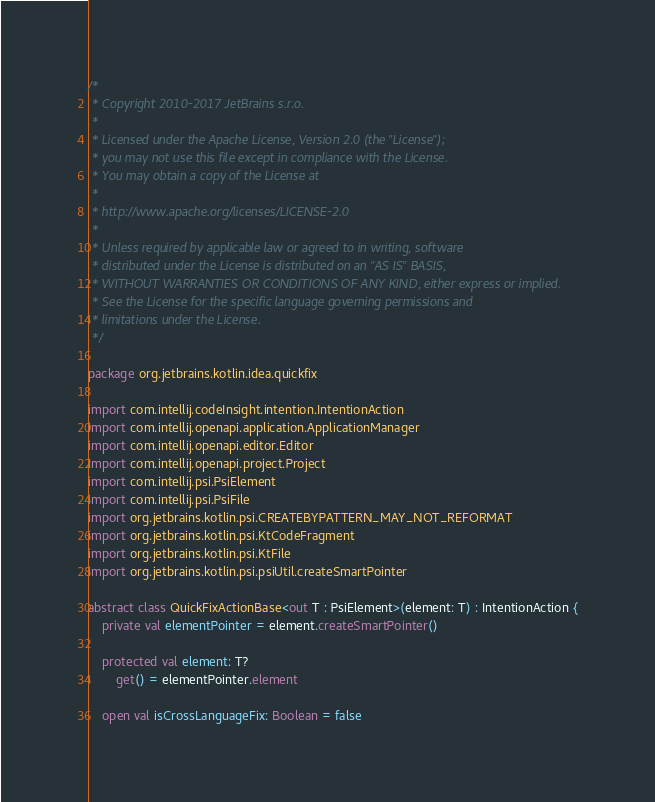<code> <loc_0><loc_0><loc_500><loc_500><_Kotlin_>/*
 * Copyright 2010-2017 JetBrains s.r.o.
 *
 * Licensed under the Apache License, Version 2.0 (the "License");
 * you may not use this file except in compliance with the License.
 * You may obtain a copy of the License at
 *
 * http://www.apache.org/licenses/LICENSE-2.0
 *
 * Unless required by applicable law or agreed to in writing, software
 * distributed under the License is distributed on an "AS IS" BASIS,
 * WITHOUT WARRANTIES OR CONDITIONS OF ANY KIND, either express or implied.
 * See the License for the specific language governing permissions and
 * limitations under the License.
 */

package org.jetbrains.kotlin.idea.quickfix

import com.intellij.codeInsight.intention.IntentionAction
import com.intellij.openapi.application.ApplicationManager
import com.intellij.openapi.editor.Editor
import com.intellij.openapi.project.Project
import com.intellij.psi.PsiElement
import com.intellij.psi.PsiFile
import org.jetbrains.kotlin.psi.CREATEBYPATTERN_MAY_NOT_REFORMAT
import org.jetbrains.kotlin.psi.KtCodeFragment
import org.jetbrains.kotlin.psi.KtFile
import org.jetbrains.kotlin.psi.psiUtil.createSmartPointer

abstract class QuickFixActionBase<out T : PsiElement>(element: T) : IntentionAction {
    private val elementPointer = element.createSmartPointer()

    protected val element: T?
        get() = elementPointer.element

    open val isCrossLanguageFix: Boolean = false
</code> 